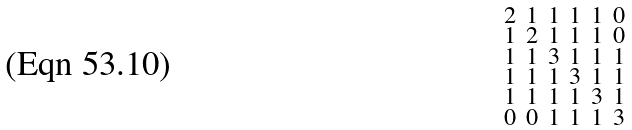Convert formula to latex. <formula><loc_0><loc_0><loc_500><loc_500>\begin{smallmatrix} 2 & 1 & 1 & 1 & 1 & 0 \\ 1 & 2 & 1 & 1 & 1 & 0 \\ 1 & 1 & 3 & 1 & 1 & 1 \\ 1 & 1 & 1 & 3 & 1 & 1 \\ 1 & 1 & 1 & 1 & 3 & 1 \\ 0 & 0 & 1 & 1 & 1 & 3 \end{smallmatrix}</formula> 